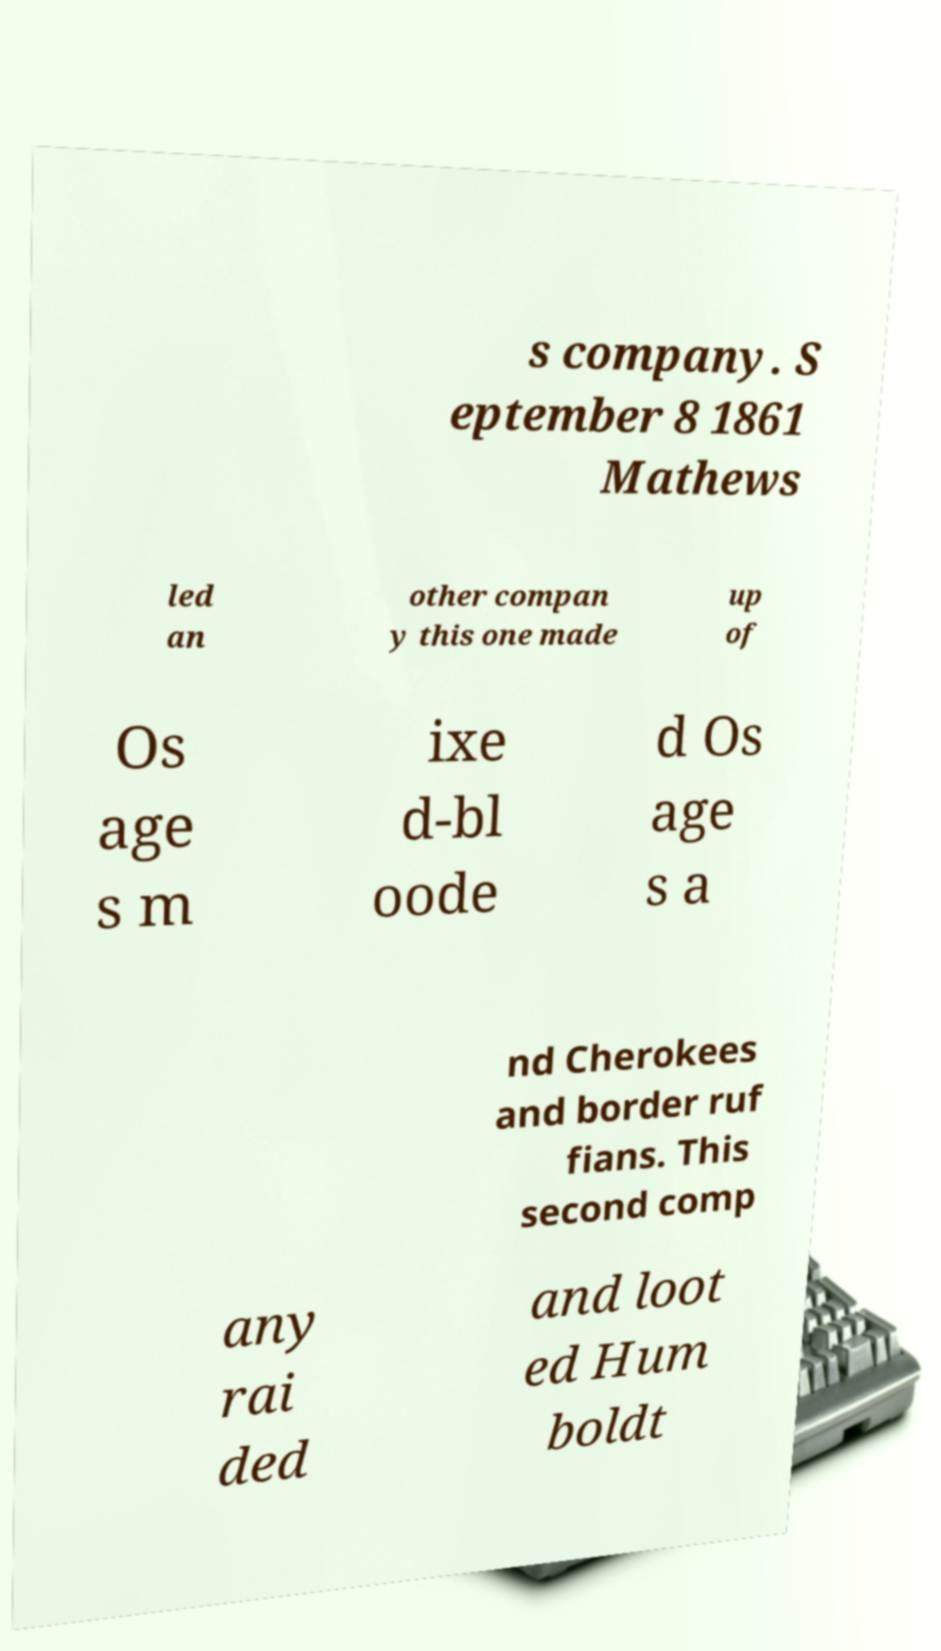There's text embedded in this image that I need extracted. Can you transcribe it verbatim? s company. S eptember 8 1861 Mathews led an other compan y this one made up of Os age s m ixe d-bl oode d Os age s a nd Cherokees and border ruf fians. This second comp any rai ded and loot ed Hum boldt 